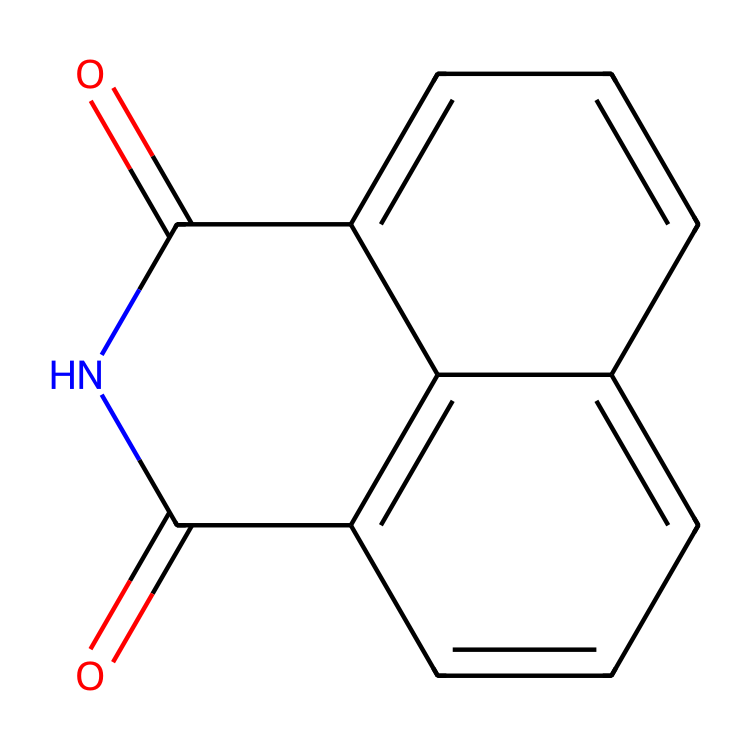How many carbon atoms are in naphthalimide? By examining the chemical structure, we can count the carbon atoms present, which are the vertices in the cyclic portions and the imide functional group. There are 12 carbon atoms in total in the structure.
Answer: 12 What type of functional groups are present in naphthalimide? The structure contains two carbonyl groups (C=O) and an imide functional group (R-CO-N-CO-R'). This indicates the presence of both amide and carbonyl functionalities.
Answer: imide, carbonyl How many nitrogen atoms are present in naphthalimide? By looking at the structure, we can identify the nitrogen atoms, which are part of the imide functional group. There are 1 nitrogen atom in this compound.
Answer: 1 What is the degree of unsaturation of naphthalimide? The degree of unsaturation can be calculated considering the number of rings and double bonds (C=O and C=C) present in the structure. Naphthalimide displays a degree of unsaturation of 6.
Answer: 6 What is the molecular formula of naphthalimide? The molecular formula can be derived from counting the total number of each type of atom in the structure: 12 carbons, 7 hydrogens, 1 nitrogen, and 2 oxygens, giving the formula C12H7N1O2.
Answer: C12H7N2O2 